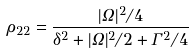Convert formula to latex. <formula><loc_0><loc_0><loc_500><loc_500>\rho _ { 2 2 } = \frac { | \Omega | ^ { 2 } / 4 } { \delta ^ { 2 } + | \Omega | ^ { 2 } / 2 + \Gamma ^ { 2 } / 4 }</formula> 